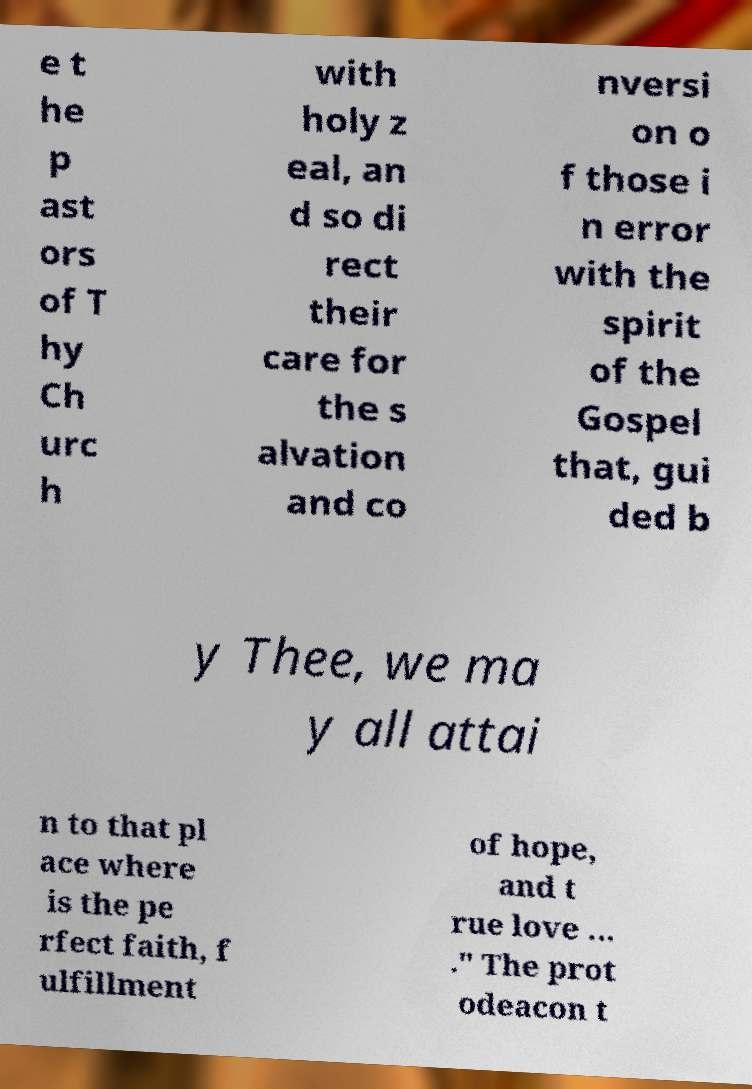Please read and relay the text visible in this image. What does it say? e t he p ast ors of T hy Ch urc h with holy z eal, an d so di rect their care for the s alvation and co nversi on o f those i n error with the spirit of the Gospel that, gui ded b y Thee, we ma y all attai n to that pl ace where is the pe rfect faith, f ulfillment of hope, and t rue love … ." The prot odeacon t 